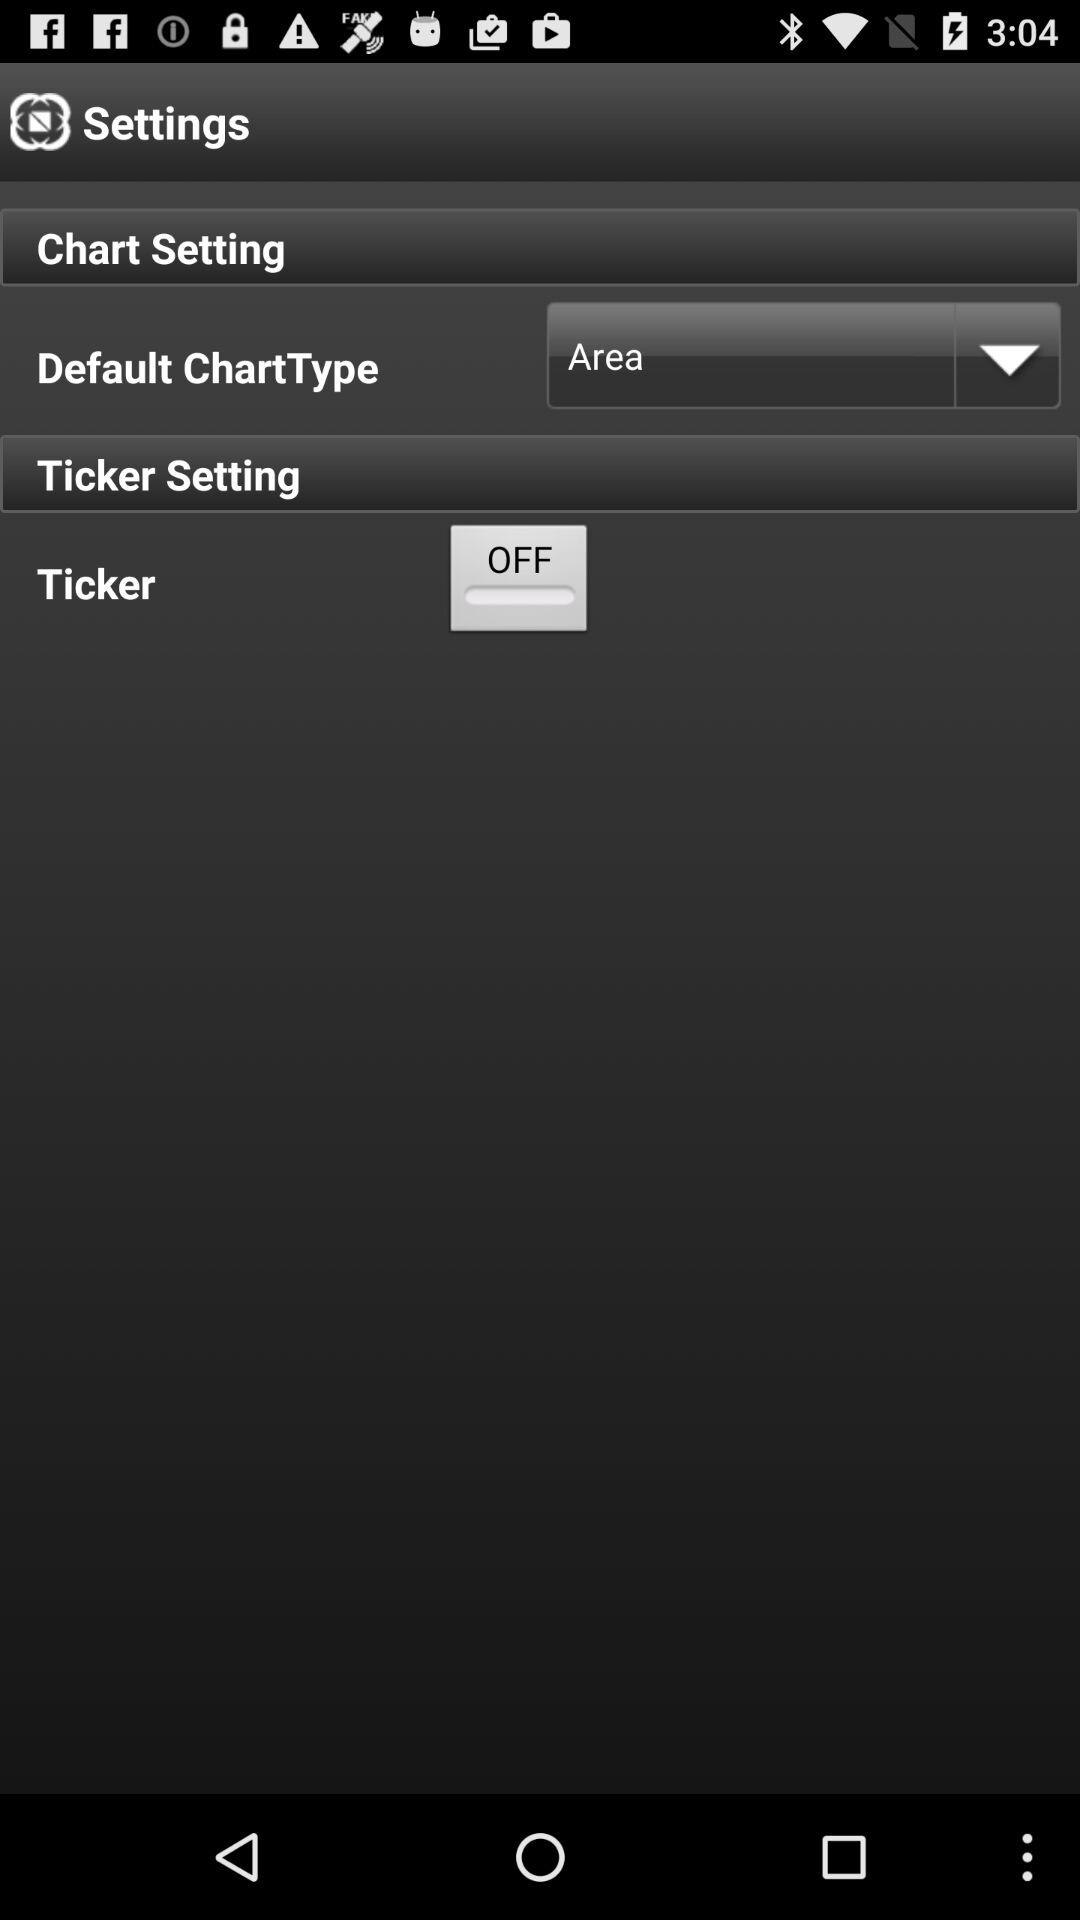Is "Ticker" on or off?
Answer the question using a single word or phrase. "Ticker" is off. 